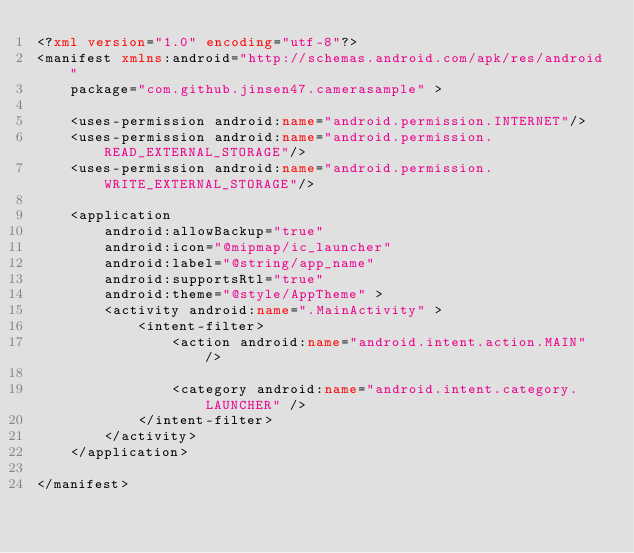Convert code to text. <code><loc_0><loc_0><loc_500><loc_500><_XML_><?xml version="1.0" encoding="utf-8"?>
<manifest xmlns:android="http://schemas.android.com/apk/res/android"
    package="com.github.jinsen47.camerasample" >

    <uses-permission android:name="android.permission.INTERNET"/>
    <uses-permission android:name="android.permission.READ_EXTERNAL_STORAGE"/>
    <uses-permission android:name="android.permission.WRITE_EXTERNAL_STORAGE"/>

    <application
        android:allowBackup="true"
        android:icon="@mipmap/ic_launcher"
        android:label="@string/app_name"
        android:supportsRtl="true"
        android:theme="@style/AppTheme" >
        <activity android:name=".MainActivity" >
            <intent-filter>
                <action android:name="android.intent.action.MAIN" />

                <category android:name="android.intent.category.LAUNCHER" />
            </intent-filter>
        </activity>
    </application>

</manifest>
</code> 